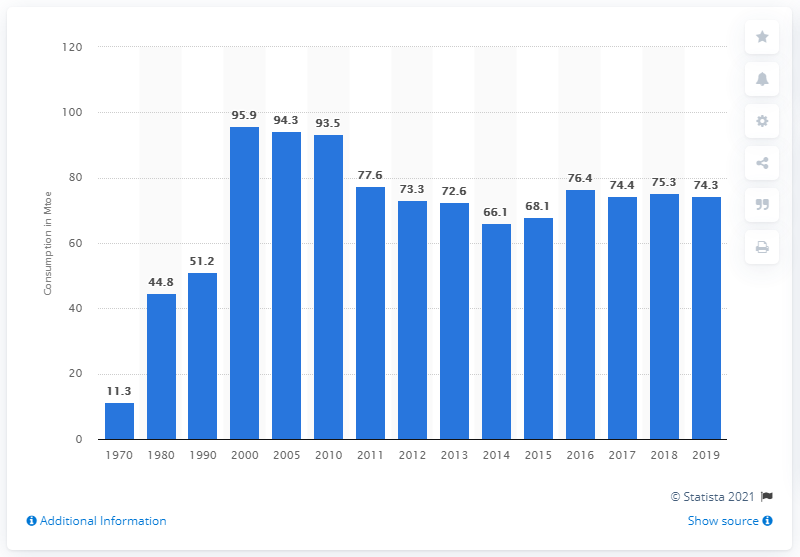Identify some key points in this picture. In 2014, a total of 66.1 units of oil equivalent were consumed. The annual consumption of natural gas for energy use from 1970 to 2000 was 11.3 terajoules per person. 